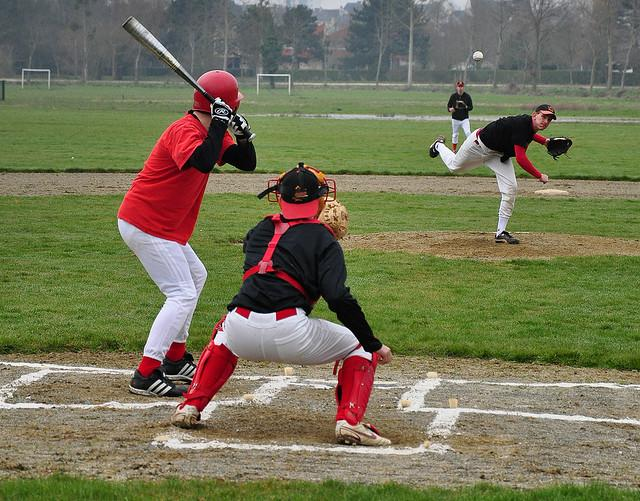What time of the year is it? spring 